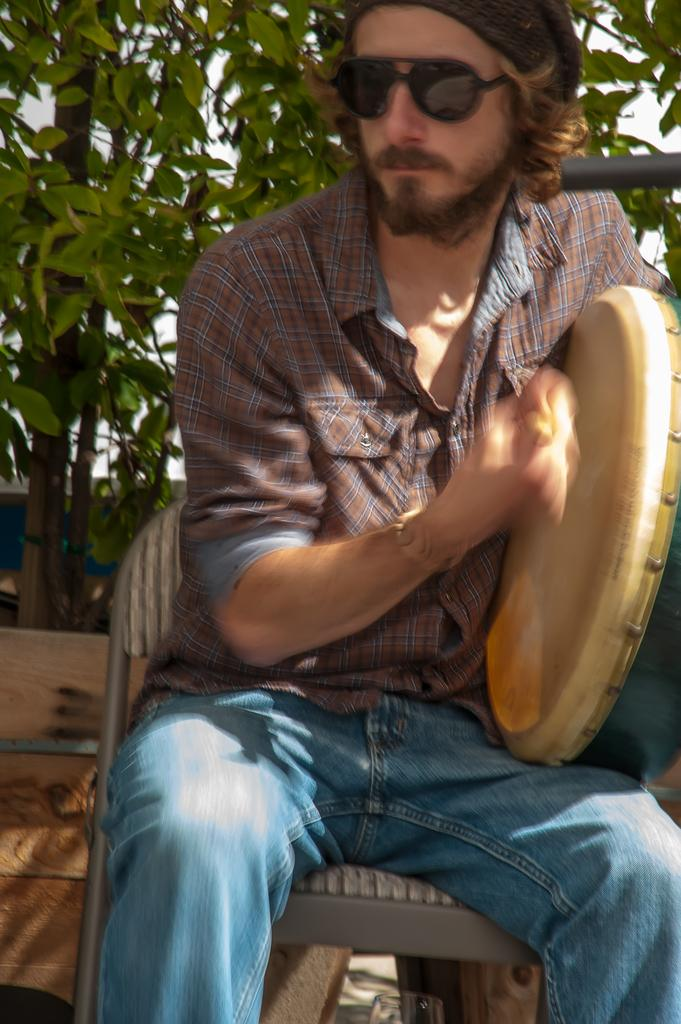What is the main subject of the image? There is a man sitting in the middle of the image. What is the man doing in the image? The man is holding a musical instrument. What can be seen in the background of the image? There are trees visible behind the man. What type of boat can be seen in the image? There is no boat present in the image; it features a man sitting and holding a musical instrument with trees in the background. 